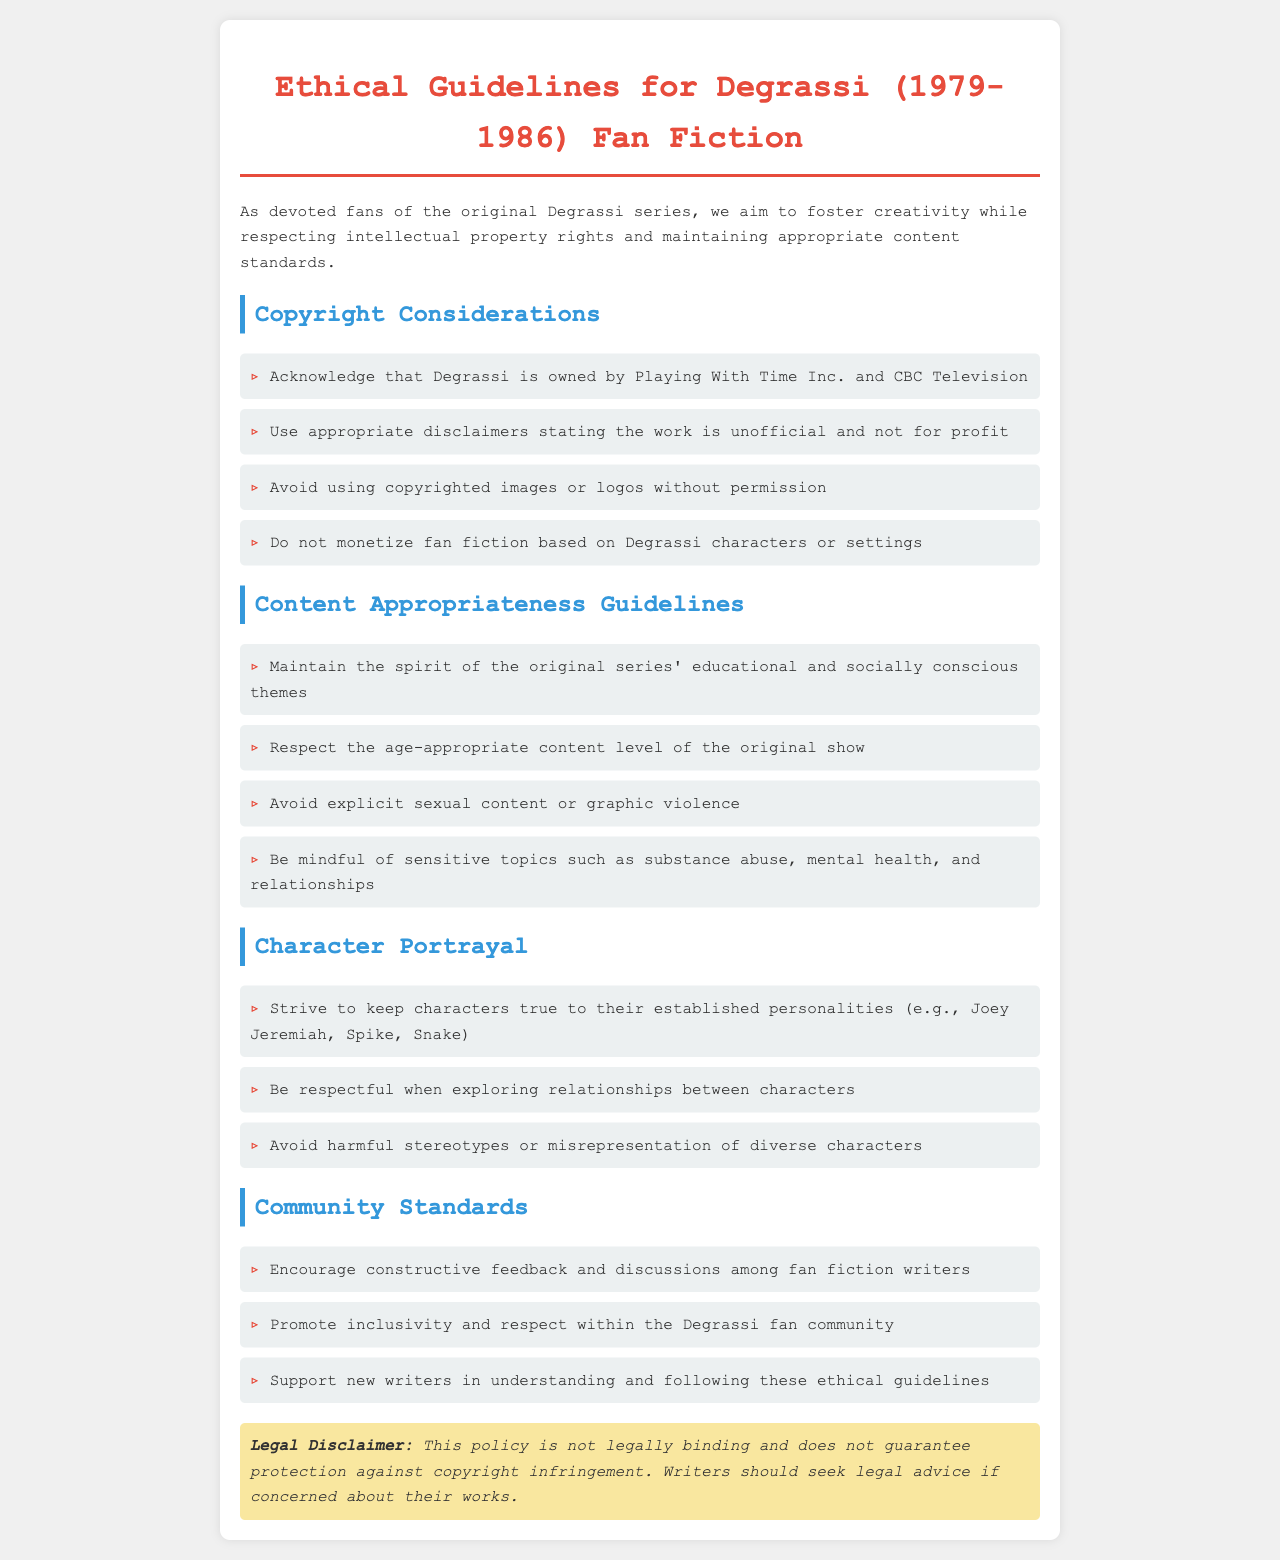what is the title of the document? The title is stated at the top of the document and indicates the subject matter concerning fan fiction.
Answer: Ethical Guidelines for Degrassi (1979-1986) Fan Fiction who owns Degrassi? The ownership of Degrassi is mentioned clearly under copyright considerations, specifying the companies.
Answer: Playing With Time Inc. and CBC Television what type of content should be avoided in fan fiction? The document lists several types of content to avoid under content appropriateness guidelines.
Answer: Explicit sexual content or graphic violence how should fan fiction writers identify their work? The guidelines recommend a specific practice regarding fan fiction writers' labeling of their works.
Answer: Use appropriate disclaimers stating the work is unofficial and not for profit what is encouraged within the Degrassi fan community? The community standards section outlines practices that should be fostered among fan fiction writers.
Answer: Constructive feedback and discussions among fan fiction writers how should characters be portrayed in fan fiction? The character portrayal section offers specific advice regarding how to maintain character integrity.
Answer: Keep characters true to their established personalities what legal advice is suggested for writers? The disclaimer section mentions the type of guidance that writers should seek if concerned about their works.
Answer: Seek legal advice if concerned about their works 